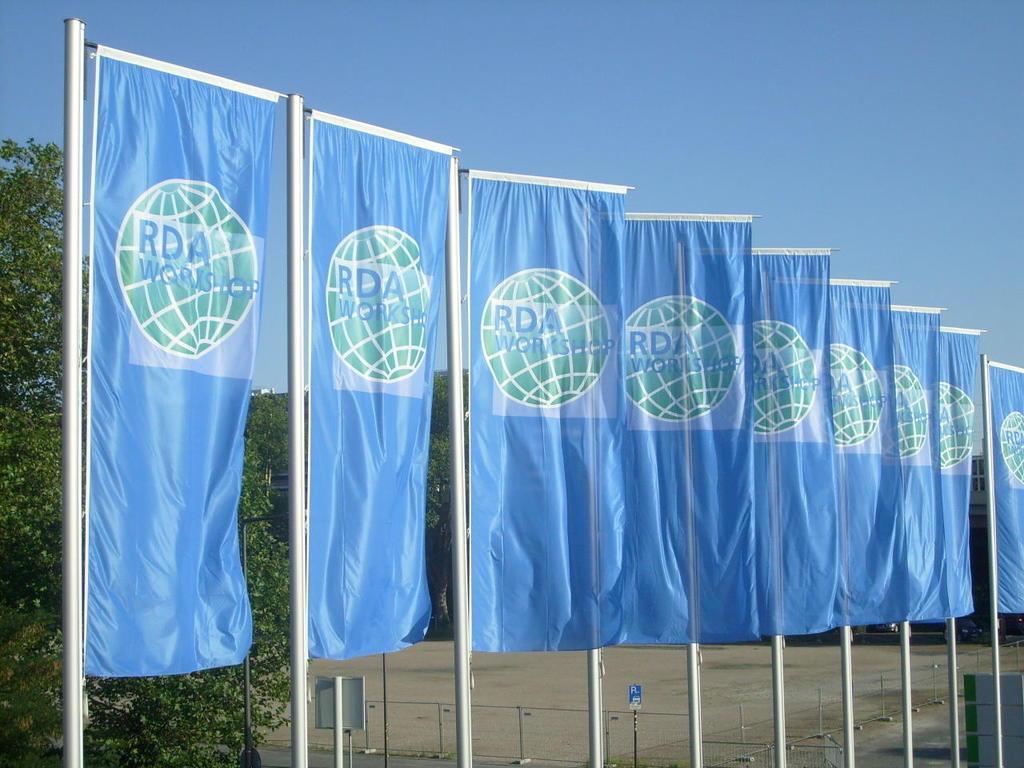Describe this image in one or two sentences. In this image, we can see some flags with text and images. We can see the ground and the fence. We can see some poles with boards. There are a few trees. We can see the sky and an object on the bottom right corner. 